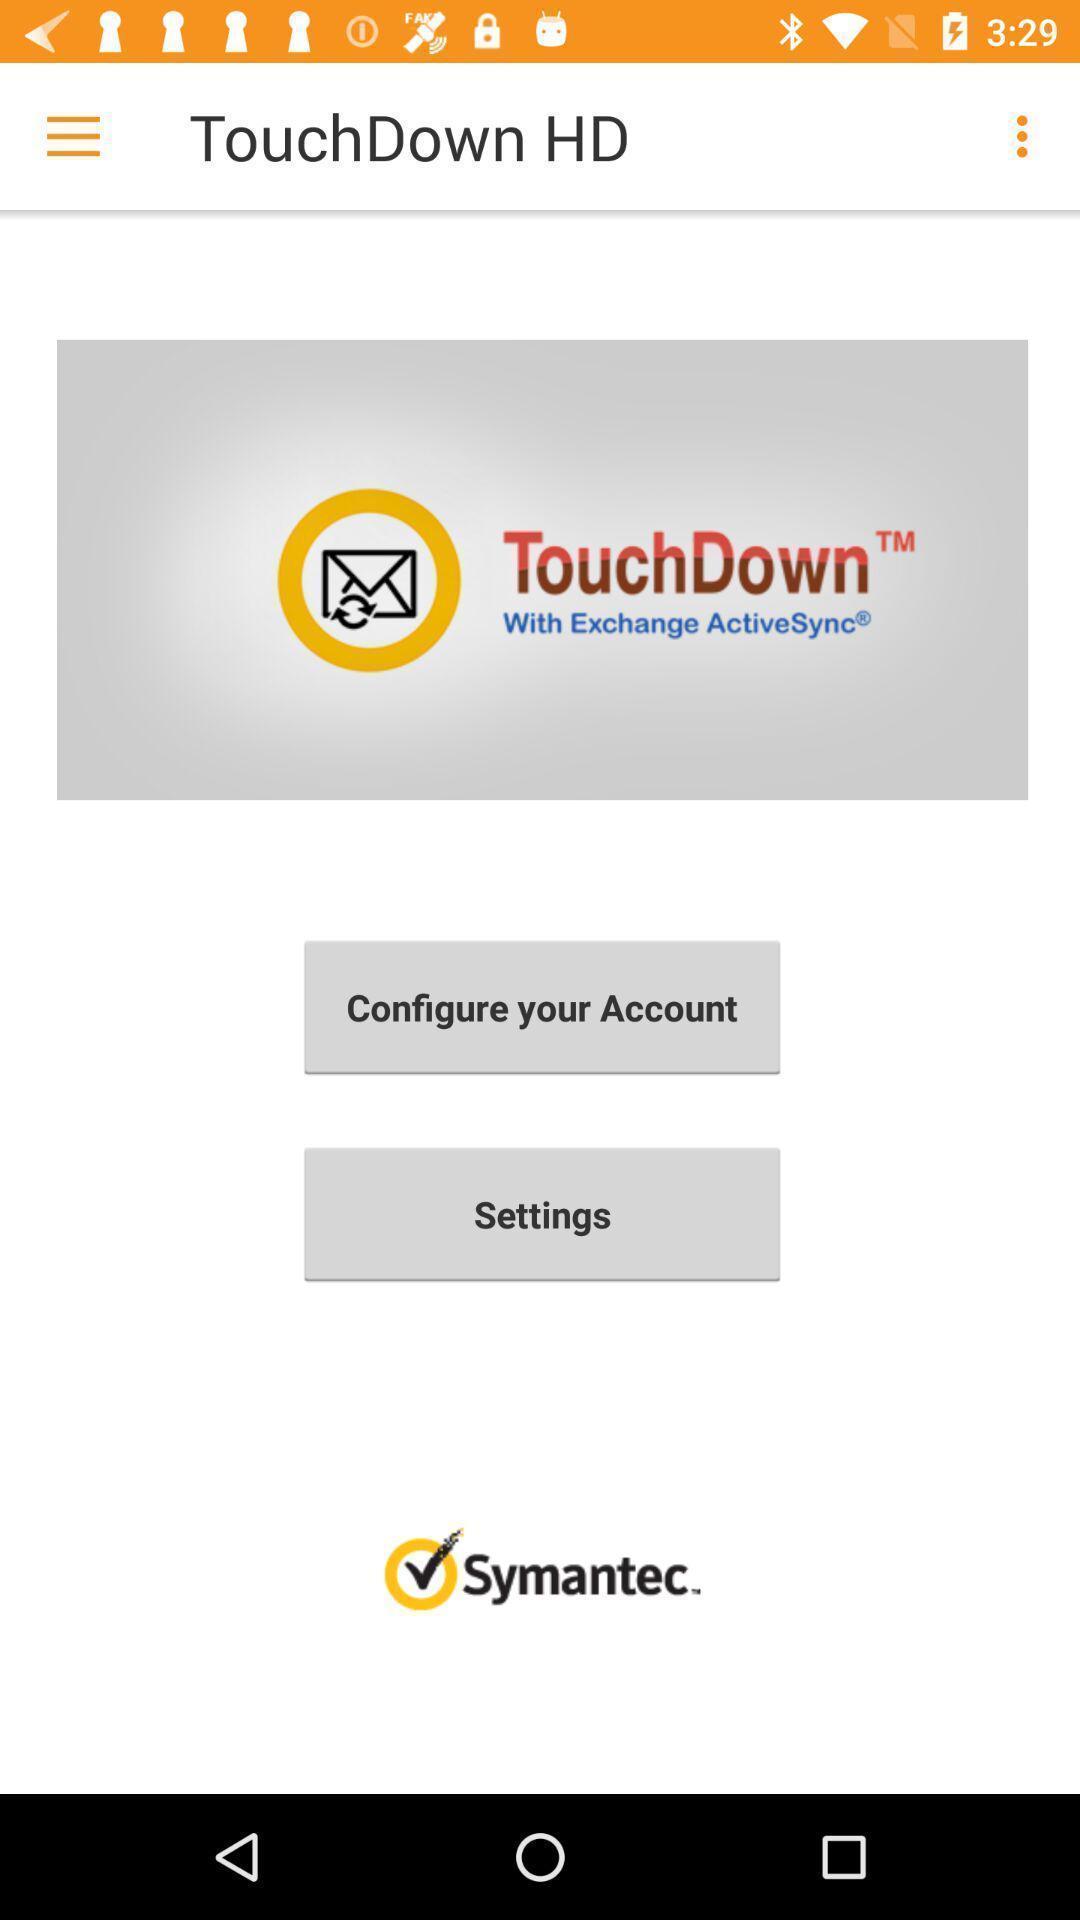Describe the content in this image. Window displaying is an exchange app. 